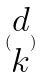Convert formula to latex. <formula><loc_0><loc_0><loc_500><loc_500>( \begin{matrix} d \\ k \end{matrix} )</formula> 